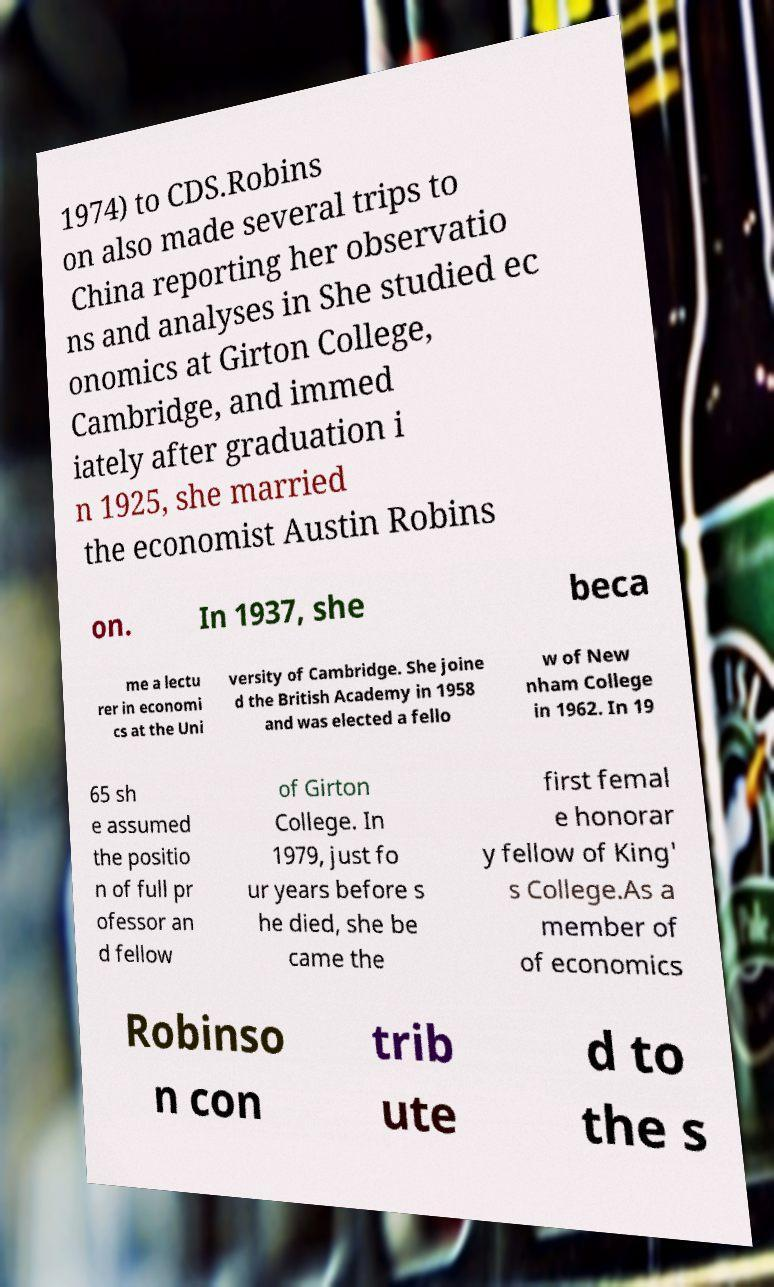Please identify and transcribe the text found in this image. 1974) to CDS.Robins on also made several trips to China reporting her observatio ns and analyses in She studied ec onomics at Girton College, Cambridge, and immed iately after graduation i n 1925, she married the economist Austin Robins on. In 1937, she beca me a lectu rer in economi cs at the Uni versity of Cambridge. She joine d the British Academy in 1958 and was elected a fello w of New nham College in 1962. In 19 65 sh e assumed the positio n of full pr ofessor an d fellow of Girton College. In 1979, just fo ur years before s he died, she be came the first femal e honorar y fellow of King' s College.As a member of of economics Robinso n con trib ute d to the s 